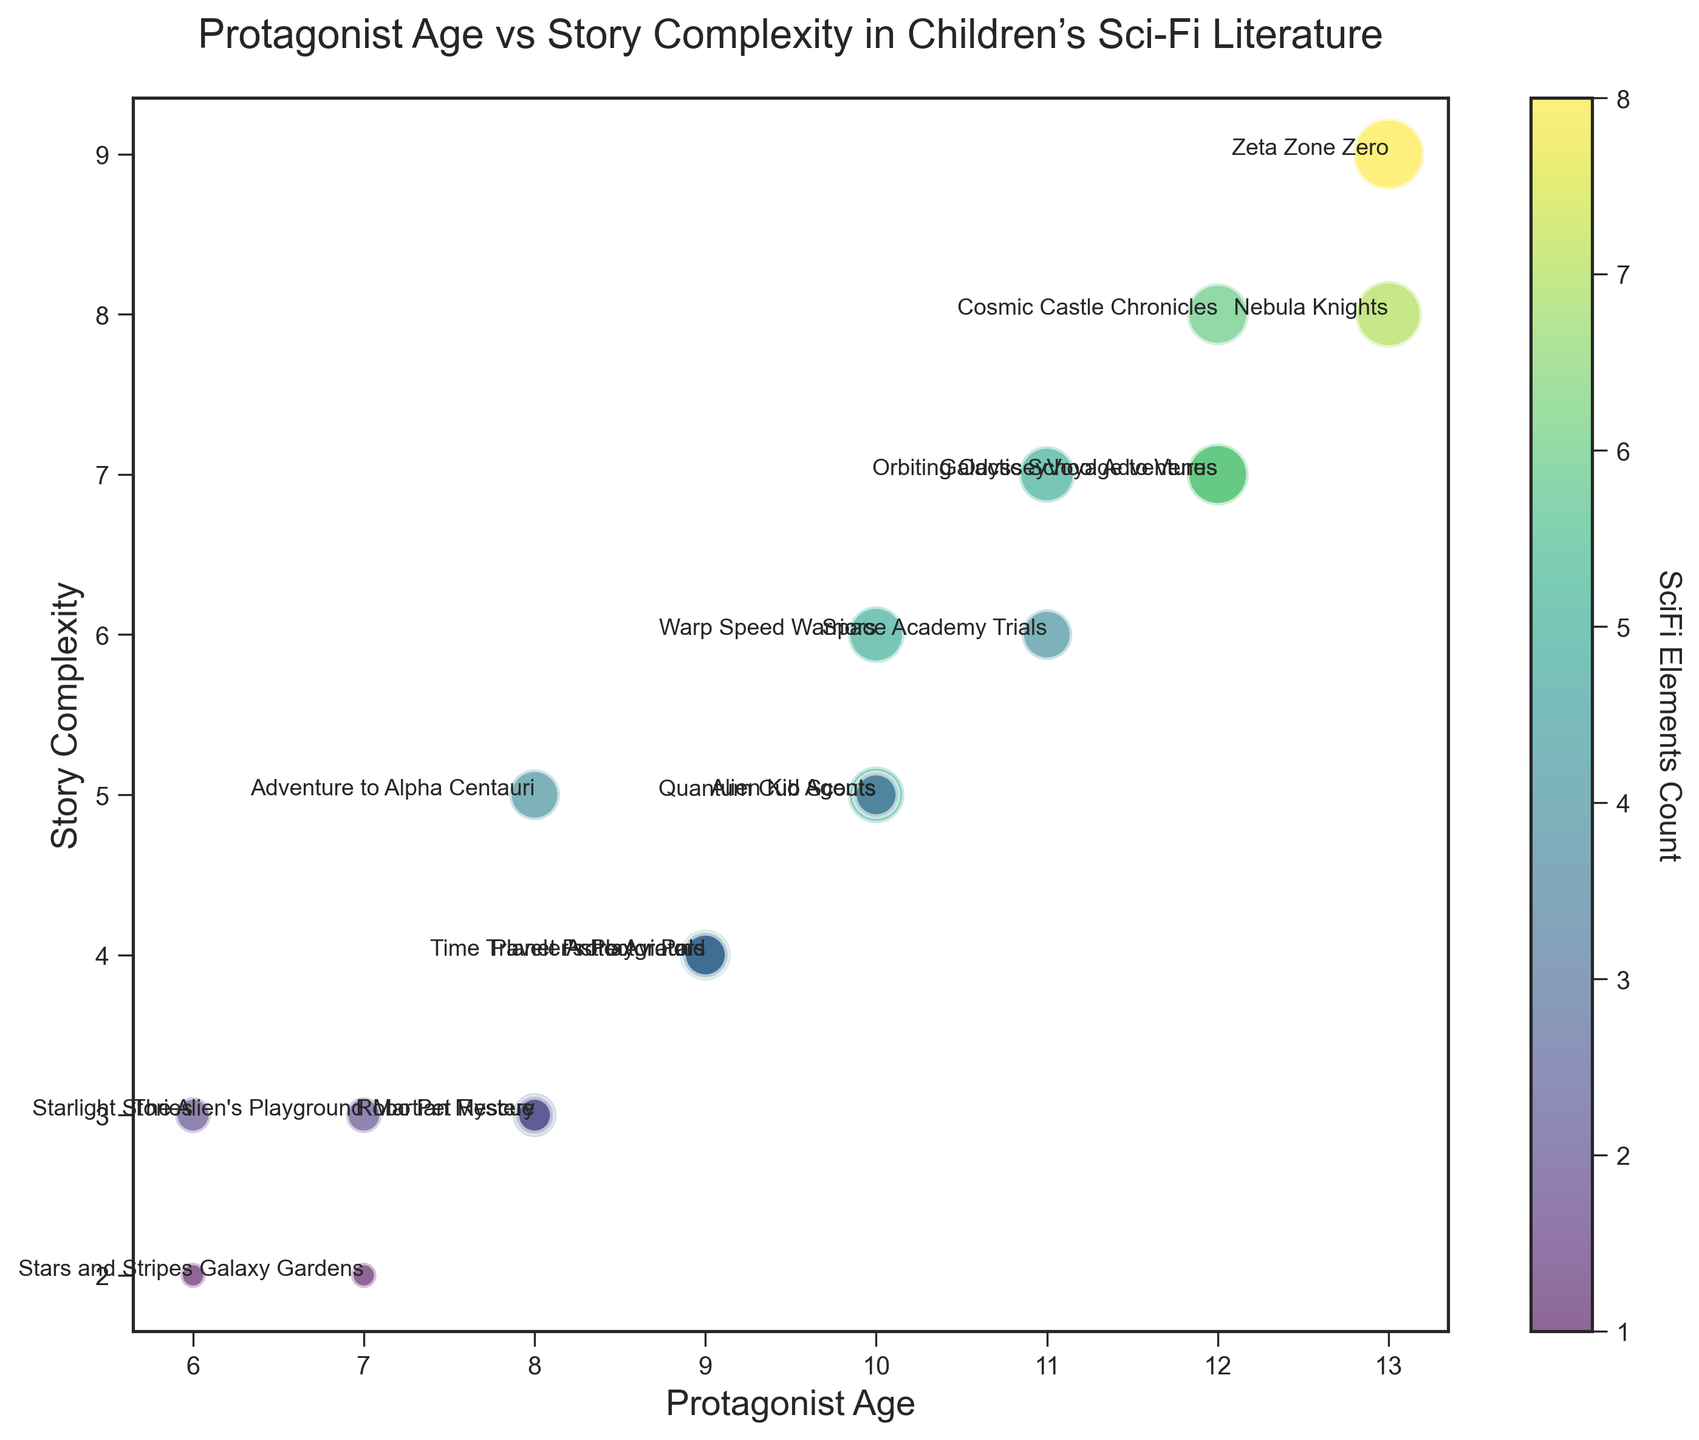What's the title of the story with the youngest protagonist? The figure shows the youngest protagonist is 6 years old. Checking annotations, the titles with 6-year-old protagonists are "Stars and Stripes" and "Starlight Stories".
Answer: "Stars and Stripes" and "Starlight Stories" Which story has the highest complexity level, and what's the protagonist's age? The highest complexity level in the figure is 9. The title annotated at this point shows "Zeta Zone Zero" with the protagonist age of 13.
Answer: "Zeta Zone Zero", 13 Which story contains the most sci-fi elements? Looking for the largest bubble (indicating the highest SciFi Elements Count), "Zeta Zone Zero" with 8 sci-fi elements stands out.
Answer: "Zeta Zone Zero" What is the average story complexity for protagonists aged 12? Check for the titles annotated with age 12, which are "Galactic School Adventures", "Cosmic Castle Chronicles", and "Voyage to Venus" with complexities 7, 8, and 7 respectively. Average = (7+8+7)/3 = 22/3 = 7.33 (approx).
Answer: 7.33 How many stories have protagonists under the age of 10 and a story complexity level of 4 or lower? Check for bubbles at age <10 and complexity ≤4. Titles: "The Alien's Playground" (age 7, complexity 3), "Galaxy Gardens" (age 7, complexity 2), "Stars and Stripes" (age 6, complexity 2), "Starlight Stories" (age 6, complexity 3), and "Planet Protector Pals" (age 9, complexity 4). Count = 5.
Answer: 5 Which story with a protagonist aged 10 has the highest sci-fi elements count? Identifying bubbles for age 10; "Quantum Cub Scouts" and "Warp Speed Warriors" both have 5 sci-fi elements, as per their annotations.
Answer: "Quantum Cub Scouts" and "Warp Speed Warriors" What is the sum of story complexity for all stories with protagonists aged 9? Check for titles annotated with age 9: "Time Traveler's Playground", "Astro Aviators", and "Planet Protector Pals" with complexities 4, 4, and 4 respectively. Sum = 4+4+4=12.
Answer: 12 Are there any stories with a higher story complexity than "Warp Speed Warriors" but fewer sci-fi elements? "Warp Speed Warriors" has a complexity of 6 and 5 sci-fi elements. Summing it up visually, titles with higher complexity (7, 8, or 9) and fewer sci-fi elements (4 or lower): None visibly fit.
Answer: No What color range represents the highest sci-fi elements count in the bubble chart? Observe the color bar beside the figure correlating colors to sci-fi elements. The highest count (8) aligns with the green/yellow range.
Answer: Green/Yellow range 